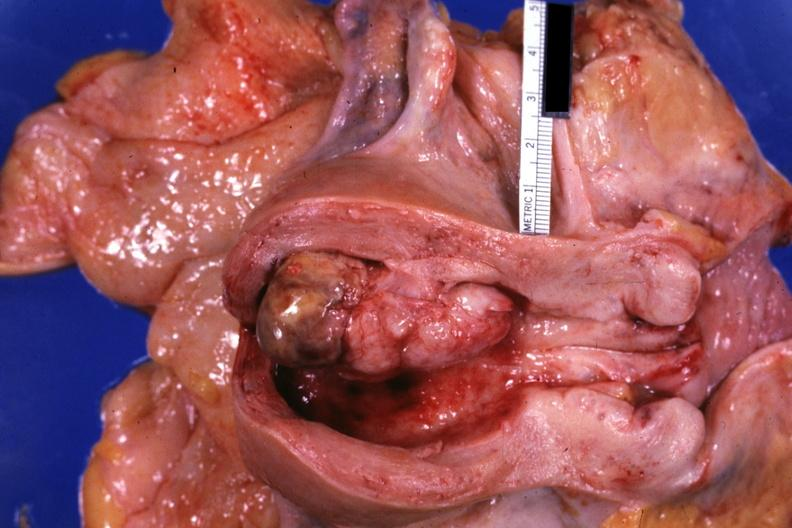what is present?
Answer the question using a single word or phrase. Mixed mesodermal tumor 